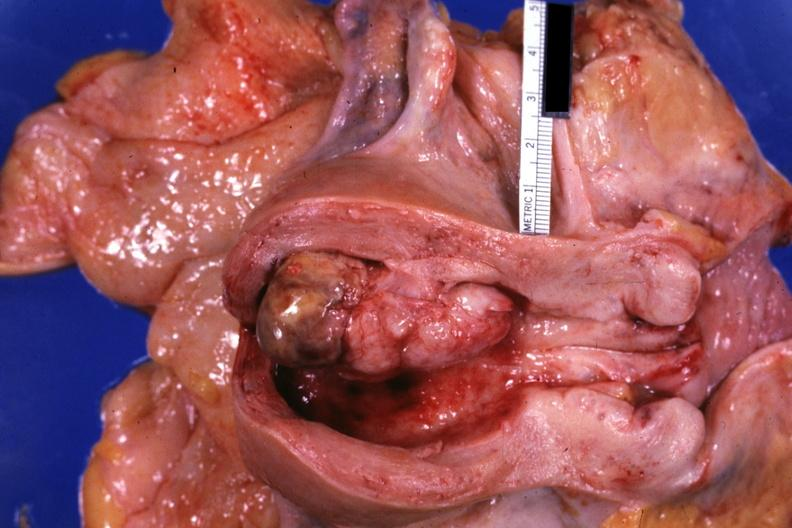what is present?
Answer the question using a single word or phrase. Mixed mesodermal tumor 